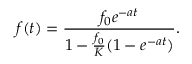Convert formula to latex. <formula><loc_0><loc_0><loc_500><loc_500>f ( t ) = \frac { f _ { 0 } e ^ { - a t } } { 1 - \frac { f _ { 0 } } { K } ( 1 - e ^ { - a t } ) } .</formula> 